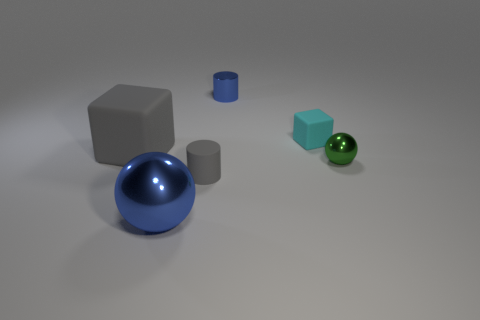Is the number of rubber cylinders that are behind the small gray matte thing less than the number of tiny green shiny things behind the small blue metal object?
Your response must be concise. No. What number of objects are either large blocks or large gray metallic cylinders?
Your answer should be compact. 1. There is a small cyan block; how many small cylinders are behind it?
Ensure brevity in your answer.  1. Does the shiny cylinder have the same color as the big shiny thing?
Provide a succinct answer. Yes. What is the shape of the other large object that is made of the same material as the green object?
Ensure brevity in your answer.  Sphere. There is a blue thing behind the tiny metallic ball; is its shape the same as the tiny gray object?
Your answer should be compact. Yes. How many brown objects are big cubes or small blocks?
Offer a very short reply. 0. Are there the same number of gray cylinders to the right of the small cyan thing and big gray cubes that are right of the rubber cylinder?
Offer a very short reply. Yes. There is a matte object left of the tiny cylinder in front of the gray matte thing that is behind the small gray cylinder; what is its color?
Your response must be concise. Gray. Is there any other thing that is the same color as the big rubber thing?
Ensure brevity in your answer.  Yes. 